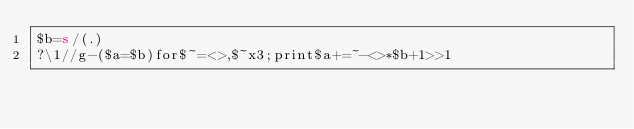<code> <loc_0><loc_0><loc_500><loc_500><_Perl_>$b=s/(.)
?\1//g-($a=$b)for$~=<>,$~x3;print$a+=~-<>*$b+1>>1</code> 